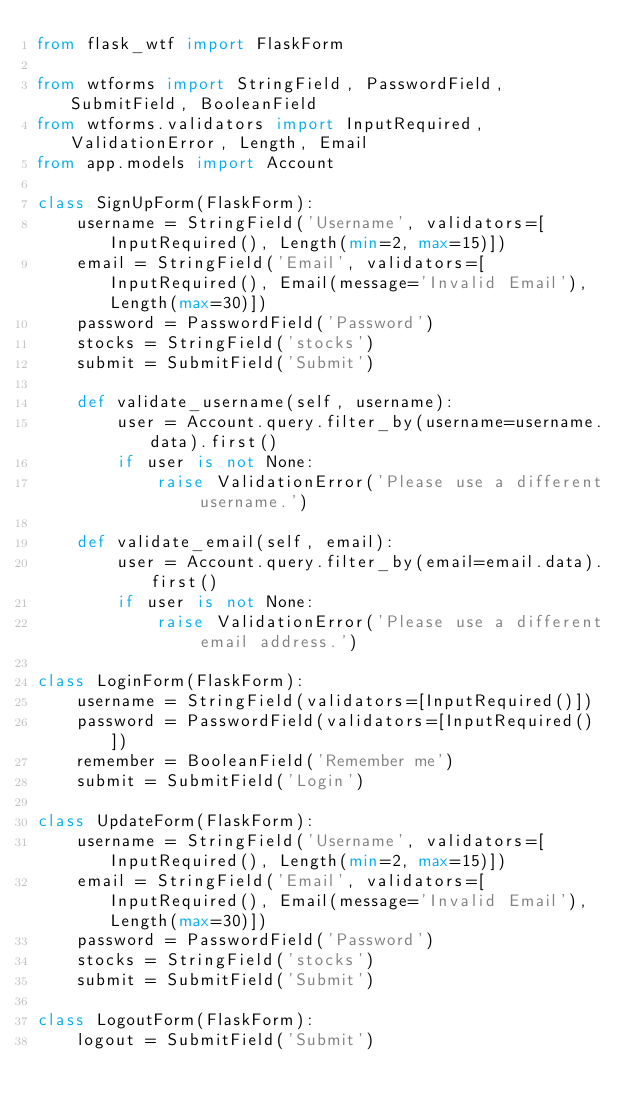Convert code to text. <code><loc_0><loc_0><loc_500><loc_500><_Python_>from flask_wtf import FlaskForm

from wtforms import StringField, PasswordField, SubmitField, BooleanField
from wtforms.validators import InputRequired, ValidationError, Length, Email
from app.models import Account

class SignUpForm(FlaskForm):
    username = StringField('Username', validators=[InputRequired(), Length(min=2, max=15)])
    email = StringField('Email', validators=[InputRequired(), Email(message='Invalid Email'), Length(max=30)])
    password = PasswordField('Password')
    stocks = StringField('stocks')
    submit = SubmitField('Submit')

    def validate_username(self, username):
        user = Account.query.filter_by(username=username.data).first()
        if user is not None:
            raise ValidationError('Please use a different username.')

    def validate_email(self, email):
        user = Account.query.filter_by(email=email.data).first()
        if user is not None:
            raise ValidationError('Please use a different email address.')

class LoginForm(FlaskForm):
    username = StringField(validators=[InputRequired()])
    password = PasswordField(validators=[InputRequired()])
    remember = BooleanField('Remember me')
    submit = SubmitField('Login')

class UpdateForm(FlaskForm):
    username = StringField('Username', validators=[InputRequired(), Length(min=2, max=15)])
    email = StringField('Email', validators=[InputRequired(), Email(message='Invalid Email'), Length(max=30)])
    password = PasswordField('Password')
    stocks = StringField('stocks')
    submit = SubmitField('Submit')
    
class LogoutForm(FlaskForm):
    logout = SubmitField('Submit')</code> 